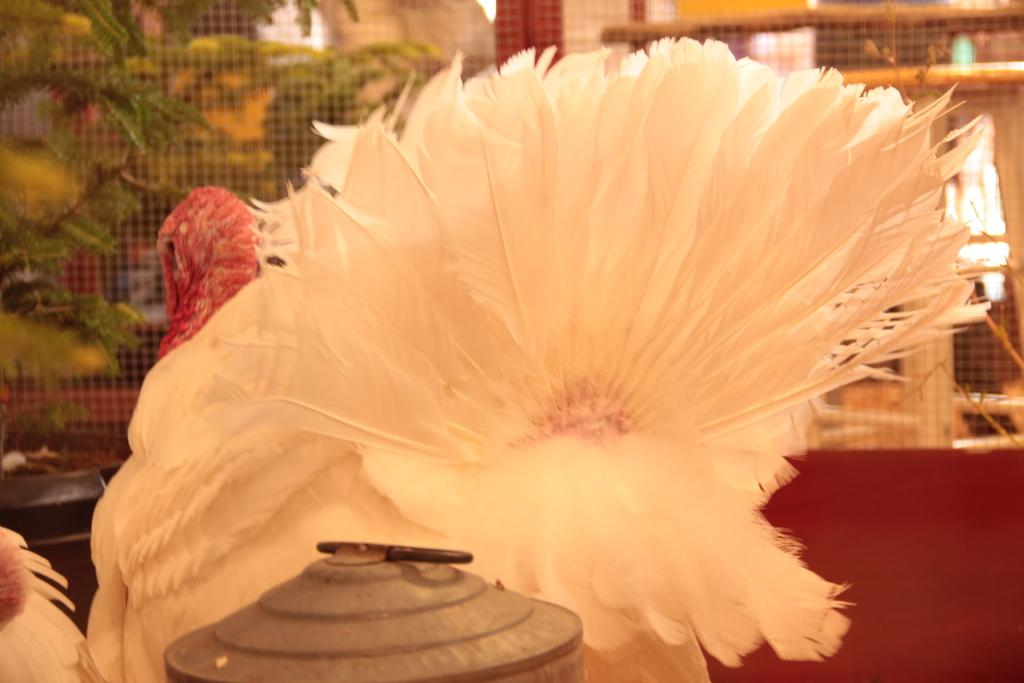What type of bird is in the center of the image? There is a white color bird in the center of the image. What is located at the bottom of the image? There is an object at the bottom of the image. What can be seen in the background of the image? There is a net and plants in the background of the image. What type of pie is being served by the bird in the image? There is no pie present in the image, and the bird is not serving anything. 